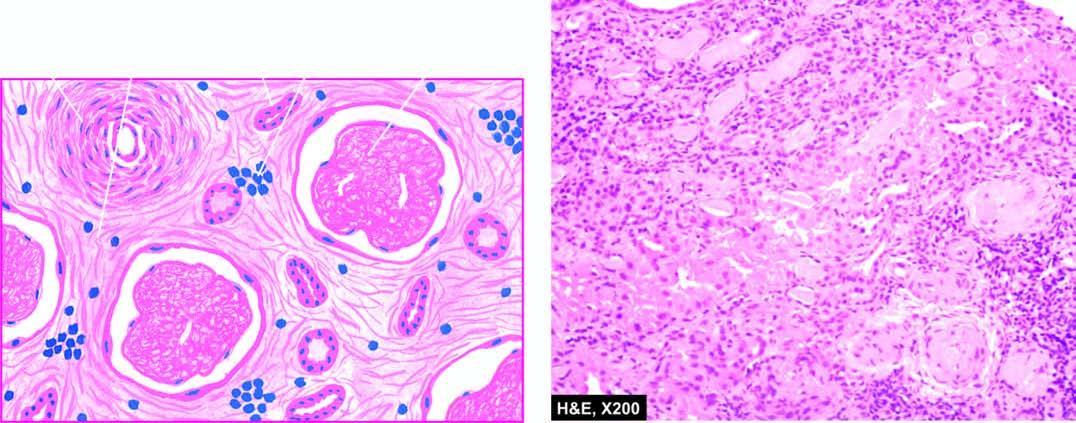does the sectioned surface show fine fibrosis and a few chronic inflammatory cells?
Answer the question using a single word or phrase. No 